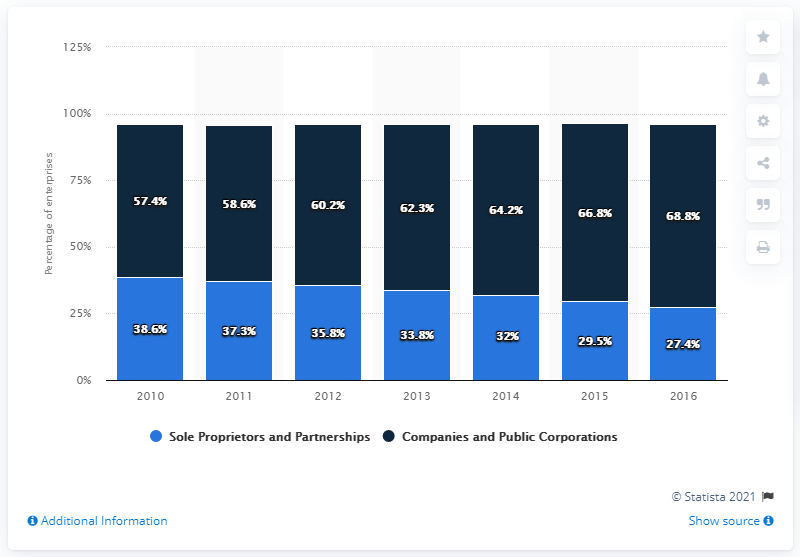Mention a couple of crucial points in this snapshot. In 2015, 66.8% of VAT and/or PAYE based enterprises in the UK were corporate businesses. 